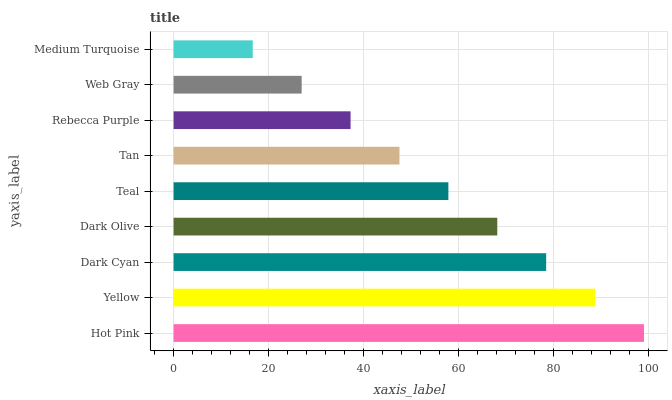Is Medium Turquoise the minimum?
Answer yes or no. Yes. Is Hot Pink the maximum?
Answer yes or no. Yes. Is Yellow the minimum?
Answer yes or no. No. Is Yellow the maximum?
Answer yes or no. No. Is Hot Pink greater than Yellow?
Answer yes or no. Yes. Is Yellow less than Hot Pink?
Answer yes or no. Yes. Is Yellow greater than Hot Pink?
Answer yes or no. No. Is Hot Pink less than Yellow?
Answer yes or no. No. Is Teal the high median?
Answer yes or no. Yes. Is Teal the low median?
Answer yes or no. Yes. Is Hot Pink the high median?
Answer yes or no. No. Is Yellow the low median?
Answer yes or no. No. 